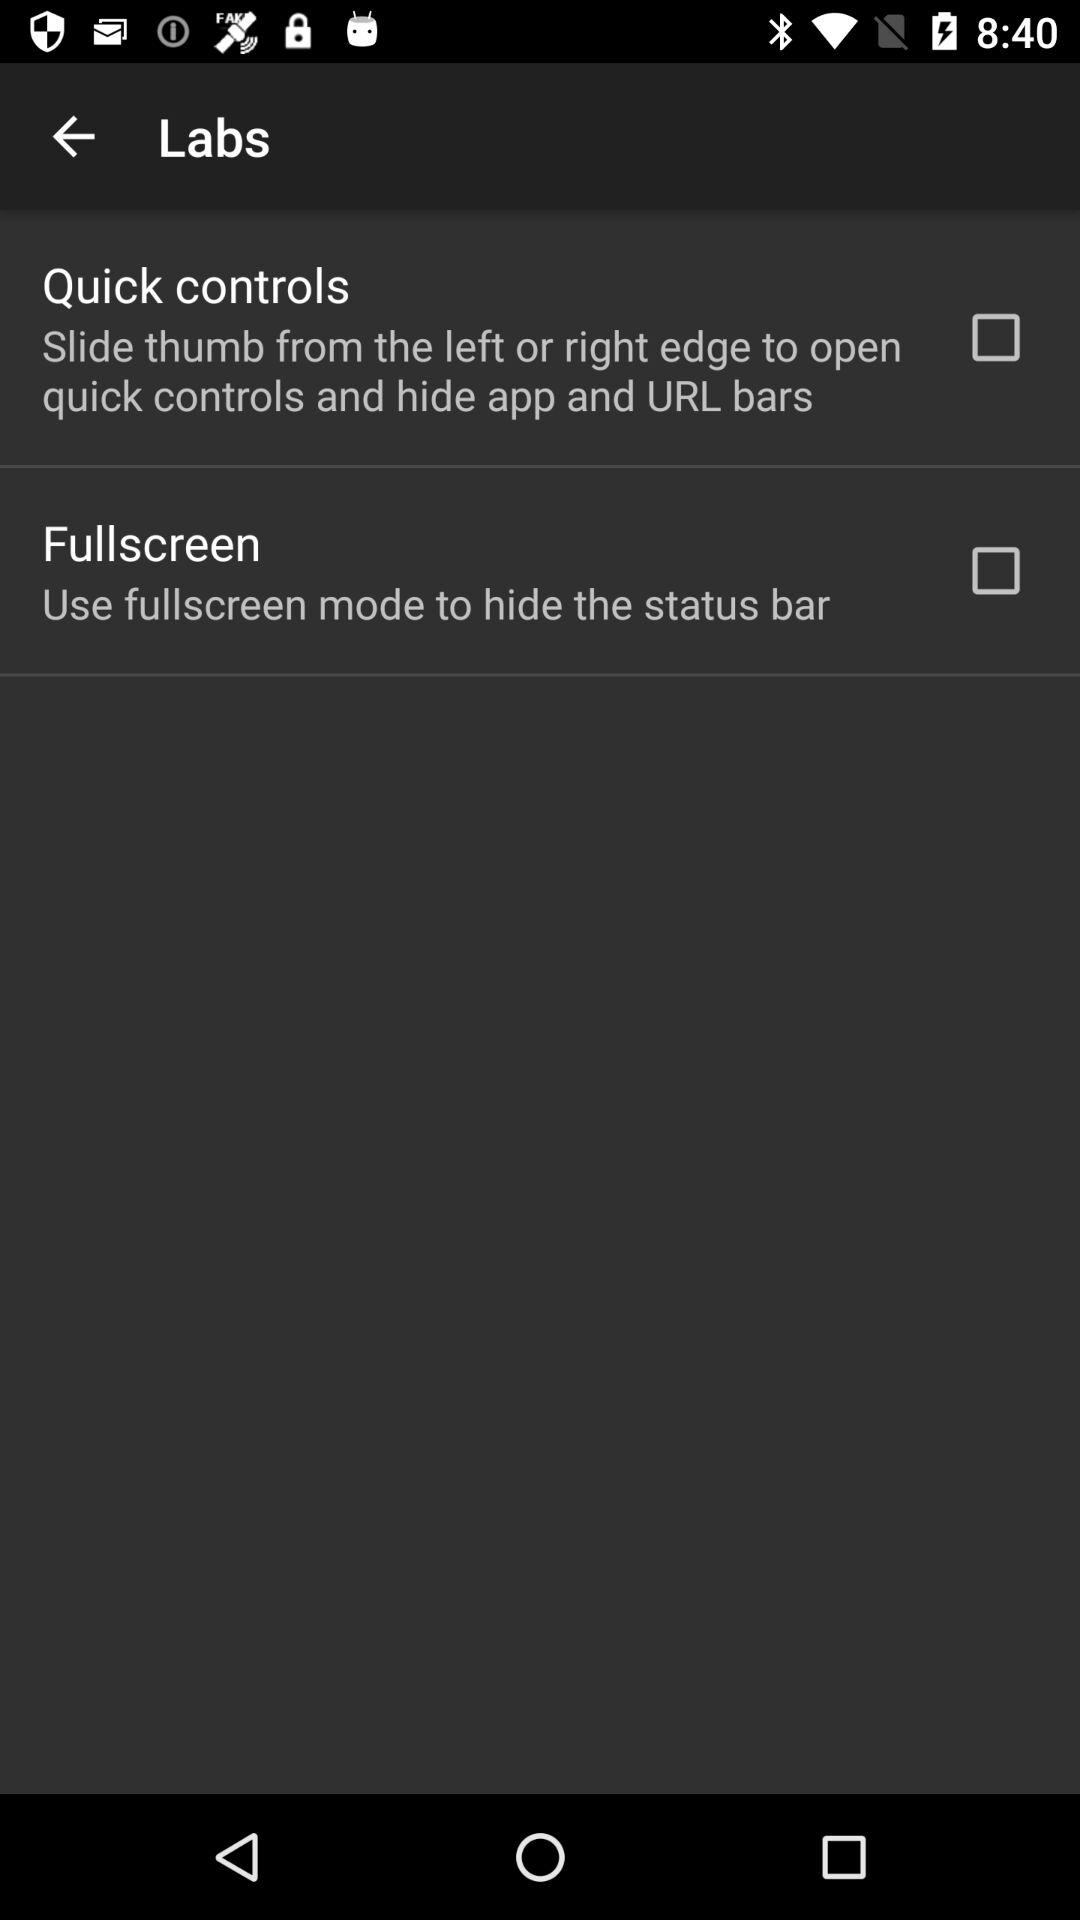What is the status of "Fullscreen"? The status of "Fullscreen" is "off". 